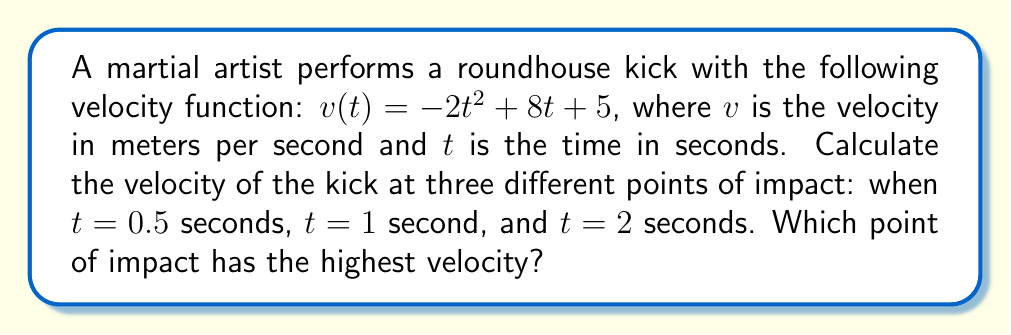Solve this math problem. To solve this problem, we need to evaluate the velocity function at the given time points:

1. At $t = 0.5$ seconds:
   $$v(0.5) = -2(0.5)^2 + 8(0.5) + 5$$
   $$= -2(0.25) + 4 + 5$$
   $$= -0.5 + 4 + 5 = 8.5 \text{ m/s}$$

2. At $t = 1$ second:
   $$v(1) = -2(1)^2 + 8(1) + 5$$
   $$= -2 + 8 + 5 = 11 \text{ m/s}$$

3. At $t = 2$ seconds:
   $$v(2) = -2(2)^2 + 8(2) + 5$$
   $$= -8 + 16 + 5 = 13 \text{ m/s}$$

Comparing the velocities:
$v(0.5) = 8.5 \text{ m/s}$
$v(1) = 11 \text{ m/s}$
$v(2) = 13 \text{ m/s}$

The highest velocity is at $t = 2$ seconds with 13 m/s.
Answer: 13 m/s at t = 2 seconds 